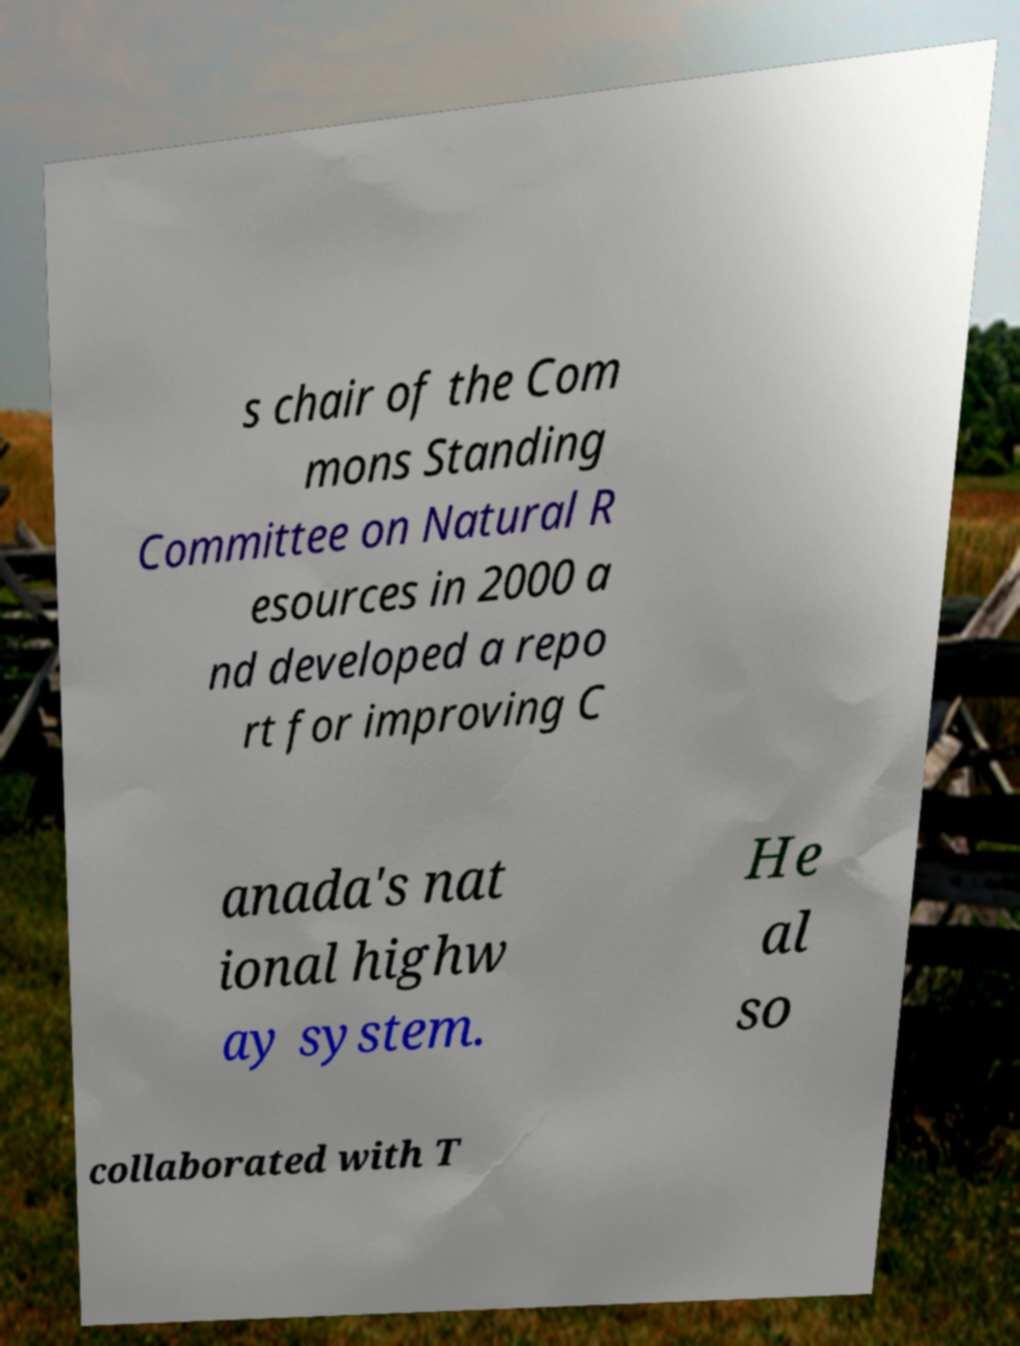For documentation purposes, I need the text within this image transcribed. Could you provide that? s chair of the Com mons Standing Committee on Natural R esources in 2000 a nd developed a repo rt for improving C anada's nat ional highw ay system. He al so collaborated with T 